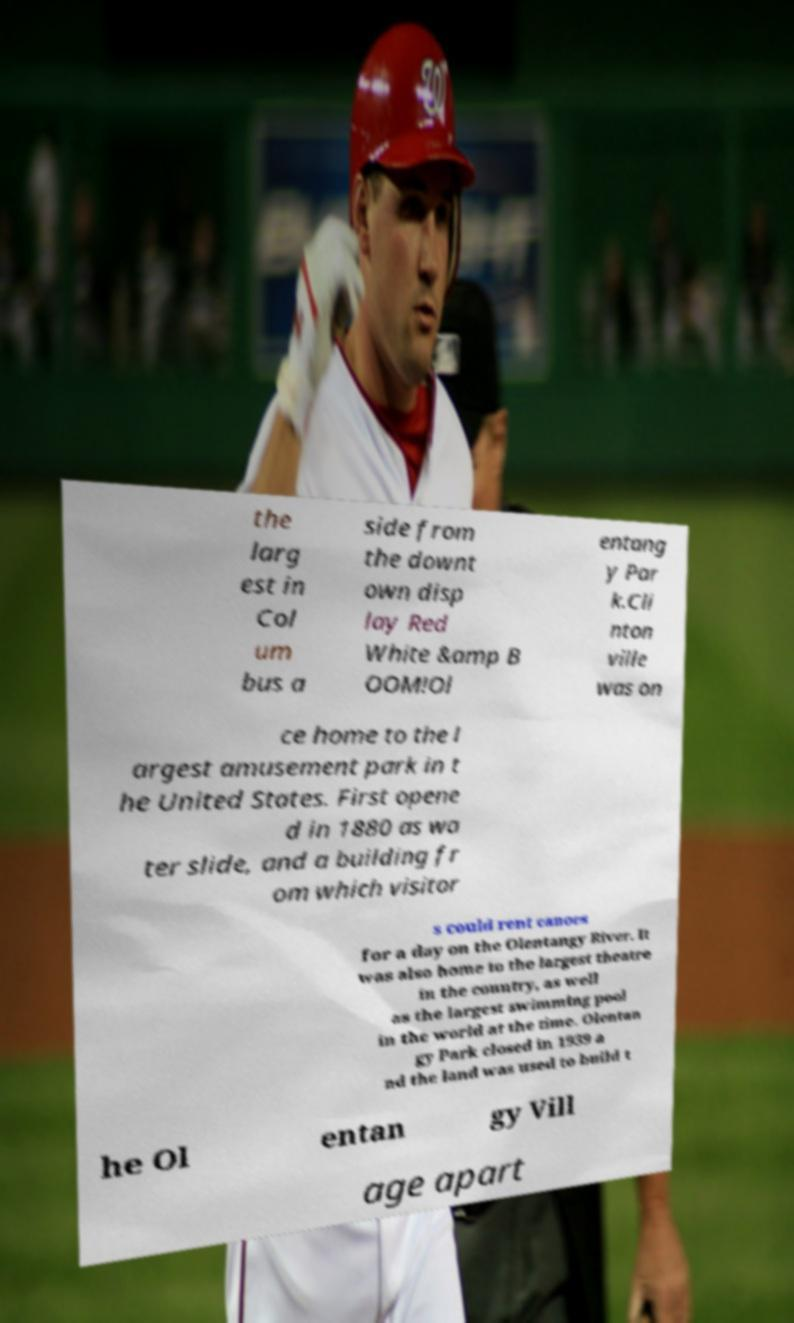Could you assist in decoding the text presented in this image and type it out clearly? the larg est in Col um bus a side from the downt own disp lay Red White &amp B OOM!Ol entang y Par k.Cli nton ville was on ce home to the l argest amusement park in t he United States. First opene d in 1880 as wa ter slide, and a building fr om which visitor s could rent canoes for a day on the Olentangy River. It was also home to the largest theatre in the country, as well as the largest swimming pool in the world at the time. Olentan gy Park closed in 1939 a nd the land was used to build t he Ol entan gy Vill age apart 